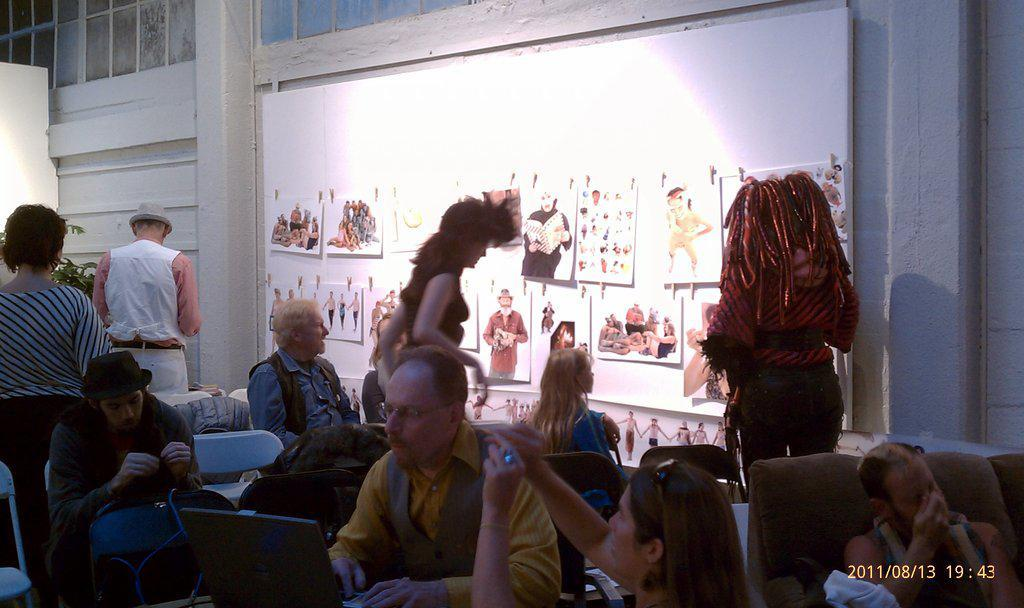What are the people in the image doing? There are persons standing and sitting on chairs in the image. Can you describe the wall on the right side of the image? There is a wall on the right side of the image, and posters are attached to it. What type of instrument does the grandmother play in the image? There is no grandmother or instrument present in the image. 